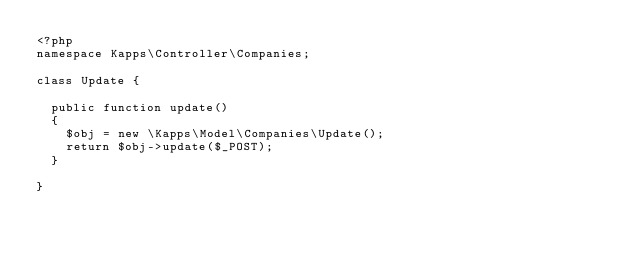Convert code to text. <code><loc_0><loc_0><loc_500><loc_500><_PHP_><?php
namespace Kapps\Controller\Companies;

class Update {

	public function update()
	{
		$obj = new \Kapps\Model\Companies\Update();
		return $obj->update($_POST);
	}

}</code> 